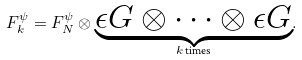Convert formula to latex. <formula><loc_0><loc_0><loc_500><loc_500>F _ { k } ^ { \psi } = F ^ { \psi } _ { N } \otimes { \underbrace { \epsilon G \otimes \cdots \otimes \epsilon G } _ { \text {$k$ times} } } .</formula> 